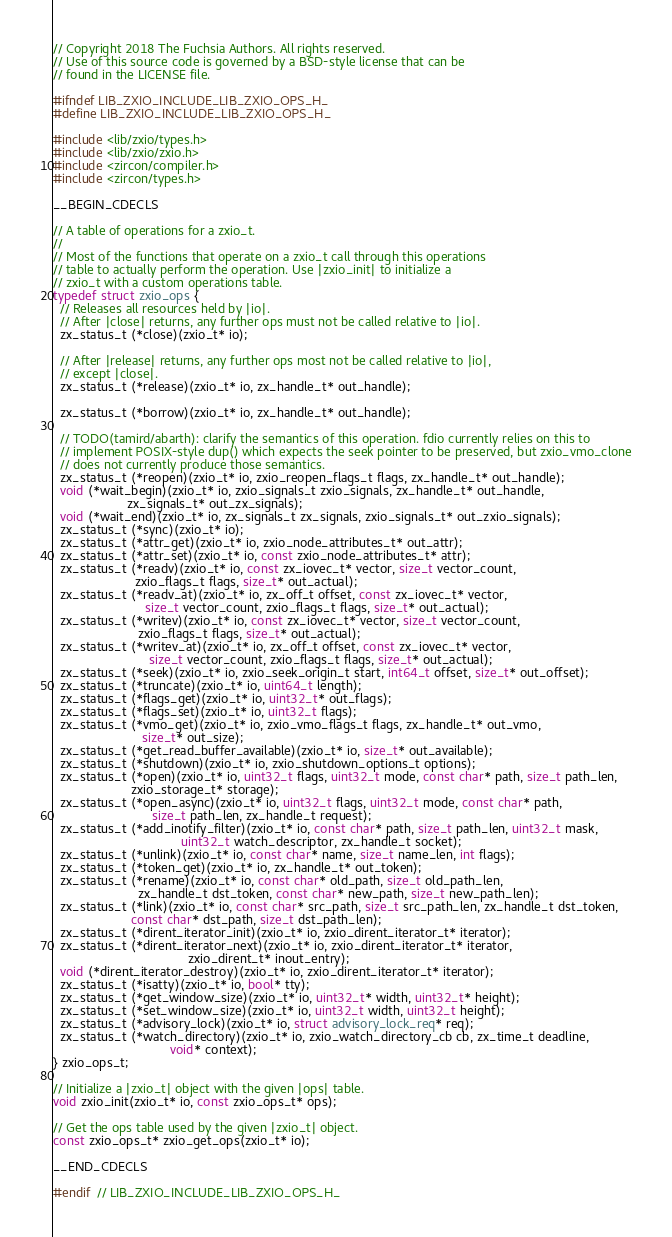<code> <loc_0><loc_0><loc_500><loc_500><_C_>// Copyright 2018 The Fuchsia Authors. All rights reserved.
// Use of this source code is governed by a BSD-style license that can be
// found in the LICENSE file.

#ifndef LIB_ZXIO_INCLUDE_LIB_ZXIO_OPS_H_
#define LIB_ZXIO_INCLUDE_LIB_ZXIO_OPS_H_

#include <lib/zxio/types.h>
#include <lib/zxio/zxio.h>
#include <zircon/compiler.h>
#include <zircon/types.h>

__BEGIN_CDECLS

// A table of operations for a zxio_t.
//
// Most of the functions that operate on a zxio_t call through this operations
// table to actually perform the operation. Use |zxio_init| to initialize a
// zxio_t with a custom operations table.
typedef struct zxio_ops {
  // Releases all resources held by |io|.
  // After |close| returns, any further ops must not be called relative to |io|.
  zx_status_t (*close)(zxio_t* io);

  // After |release| returns, any further ops most not be called relative to |io|,
  // except |close|.
  zx_status_t (*release)(zxio_t* io, zx_handle_t* out_handle);

  zx_status_t (*borrow)(zxio_t* io, zx_handle_t* out_handle);

  // TODO(tamird/abarth): clarify the semantics of this operation. fdio currently relies on this to
  // implement POSIX-style dup() which expects the seek pointer to be preserved, but zxio_vmo_clone
  // does not currently produce those semantics.
  zx_status_t (*reopen)(zxio_t* io, zxio_reopen_flags_t flags, zx_handle_t* out_handle);
  void (*wait_begin)(zxio_t* io, zxio_signals_t zxio_signals, zx_handle_t* out_handle,
                     zx_signals_t* out_zx_signals);
  void (*wait_end)(zxio_t* io, zx_signals_t zx_signals, zxio_signals_t* out_zxio_signals);
  zx_status_t (*sync)(zxio_t* io);
  zx_status_t (*attr_get)(zxio_t* io, zxio_node_attributes_t* out_attr);
  zx_status_t (*attr_set)(zxio_t* io, const zxio_node_attributes_t* attr);
  zx_status_t (*readv)(zxio_t* io, const zx_iovec_t* vector, size_t vector_count,
                       zxio_flags_t flags, size_t* out_actual);
  zx_status_t (*readv_at)(zxio_t* io, zx_off_t offset, const zx_iovec_t* vector,
                          size_t vector_count, zxio_flags_t flags, size_t* out_actual);
  zx_status_t (*writev)(zxio_t* io, const zx_iovec_t* vector, size_t vector_count,
                        zxio_flags_t flags, size_t* out_actual);
  zx_status_t (*writev_at)(zxio_t* io, zx_off_t offset, const zx_iovec_t* vector,
                           size_t vector_count, zxio_flags_t flags, size_t* out_actual);
  zx_status_t (*seek)(zxio_t* io, zxio_seek_origin_t start, int64_t offset, size_t* out_offset);
  zx_status_t (*truncate)(zxio_t* io, uint64_t length);
  zx_status_t (*flags_get)(zxio_t* io, uint32_t* out_flags);
  zx_status_t (*flags_set)(zxio_t* io, uint32_t flags);
  zx_status_t (*vmo_get)(zxio_t* io, zxio_vmo_flags_t flags, zx_handle_t* out_vmo,
                         size_t* out_size);
  zx_status_t (*get_read_buffer_available)(zxio_t* io, size_t* out_available);
  zx_status_t (*shutdown)(zxio_t* io, zxio_shutdown_options_t options);
  zx_status_t (*open)(zxio_t* io, uint32_t flags, uint32_t mode, const char* path, size_t path_len,
                      zxio_storage_t* storage);
  zx_status_t (*open_async)(zxio_t* io, uint32_t flags, uint32_t mode, const char* path,
                            size_t path_len, zx_handle_t request);
  zx_status_t (*add_inotify_filter)(zxio_t* io, const char* path, size_t path_len, uint32_t mask,
                                    uint32_t watch_descriptor, zx_handle_t socket);
  zx_status_t (*unlink)(zxio_t* io, const char* name, size_t name_len, int flags);
  zx_status_t (*token_get)(zxio_t* io, zx_handle_t* out_token);
  zx_status_t (*rename)(zxio_t* io, const char* old_path, size_t old_path_len,
                        zx_handle_t dst_token, const char* new_path, size_t new_path_len);
  zx_status_t (*link)(zxio_t* io, const char* src_path, size_t src_path_len, zx_handle_t dst_token,
                      const char* dst_path, size_t dst_path_len);
  zx_status_t (*dirent_iterator_init)(zxio_t* io, zxio_dirent_iterator_t* iterator);
  zx_status_t (*dirent_iterator_next)(zxio_t* io, zxio_dirent_iterator_t* iterator,
                                      zxio_dirent_t* inout_entry);
  void (*dirent_iterator_destroy)(zxio_t* io, zxio_dirent_iterator_t* iterator);
  zx_status_t (*isatty)(zxio_t* io, bool* tty);
  zx_status_t (*get_window_size)(zxio_t* io, uint32_t* width, uint32_t* height);
  zx_status_t (*set_window_size)(zxio_t* io, uint32_t width, uint32_t height);
  zx_status_t (*advisory_lock)(zxio_t* io, struct advisory_lock_req* req);
  zx_status_t (*watch_directory)(zxio_t* io, zxio_watch_directory_cb cb, zx_time_t deadline,
                                 void* context);
} zxio_ops_t;

// Initialize a |zxio_t| object with the given |ops| table.
void zxio_init(zxio_t* io, const zxio_ops_t* ops);

// Get the ops table used by the given |zxio_t| object.
const zxio_ops_t* zxio_get_ops(zxio_t* io);

__END_CDECLS

#endif  // LIB_ZXIO_INCLUDE_LIB_ZXIO_OPS_H_
</code> 